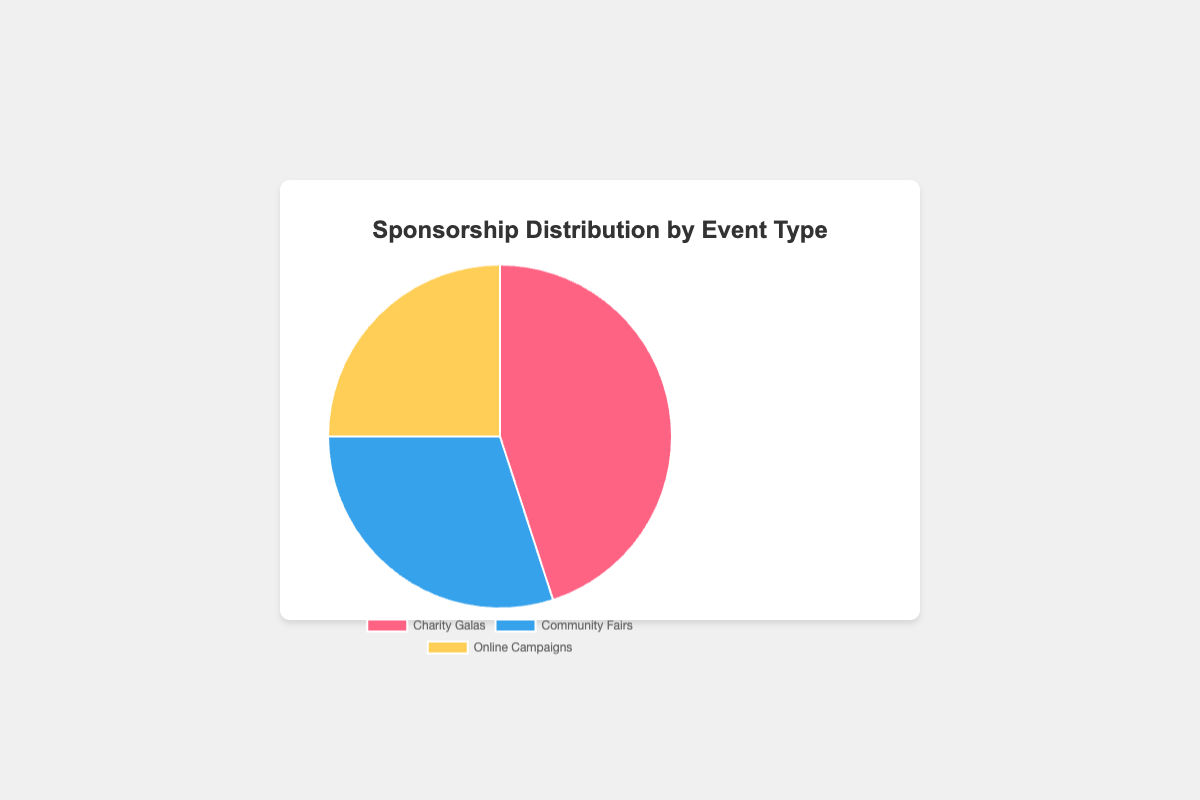What's the total amount of sponsorship for all event types combined? To calculate the total amount of sponsorship, add the amounts for Charity Galas, Community Fairs, and Online Campaigns. 450,000 (Charity Galas) + 300,000 (Community Fairs) + 250,000 (Online Campaigns) equals 1,000,000.
Answer: 1,000,000 Which event type received the least amount of sponsorship? To determine which event type received the least amount of sponsorship, compare the values for each event type. Online Campaigns received 250,000, which is less than Community Fairs' 300,000 and Charity Galas' 450,000.
Answer: Online Campaigns How much more sponsorship did Charity Galas receive compared to Community Fairs? Subtract the amount of sponsorship for Community Fairs from that of Charity Galas. 450,000 (Charity Galas) - 300,000 (Community Fairs) equals 150,000.
Answer: 150,000 What is the difference in the percentage of total sponsorship between Charity Galas and Online Campaigns? Subtract the percentage of total sponsorship of Online Campaigns from that of Charity Galas. 45% (Charity Galas) - 25% (Online Campaigns) equals 20%.
Answer: 20% If the total sponsorship amount was increased to 1.2 million while the proportions remained the same, how much sponsorship would Charity Galas receive? Calculate the new sponsorship amount for Charity Galas using the given percentage. 45% of 1.2 million is 0.45 * 1,200,000 = 540,000.
Answer: 540,000 What color represents Community Fairs in the pie chart? Observe the pie chart and identify the color of the slice corresponding to Community Fairs. Community Fairs are represented by the blue slice.
Answer: Blue 